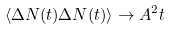<formula> <loc_0><loc_0><loc_500><loc_500>\langle \Delta N ( t ) \Delta N ( t ) \rangle \to A ^ { 2 } t</formula> 